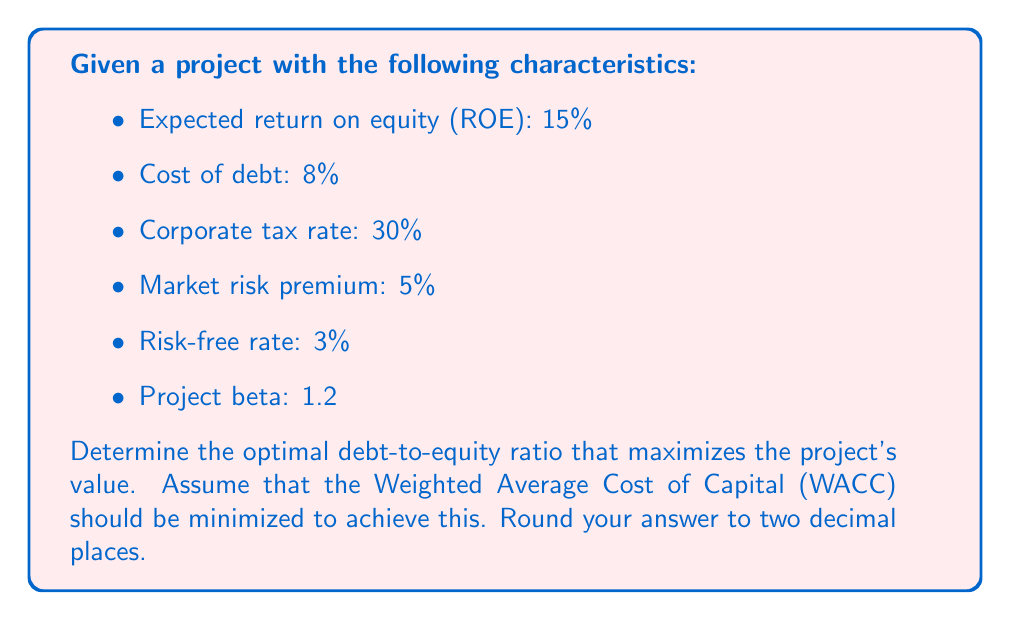Can you solve this math problem? To determine the optimal debt-to-equity ratio, we need to minimize the Weighted Average Cost of Capital (WACC). We'll use the following steps:

1. Calculate the cost of equity using the Capital Asset Pricing Model (CAPM):
   $$ K_e = R_f + \beta(R_m - R_f) $$
   Where:
   $K_e$ = Cost of equity
   $R_f$ = Risk-free rate
   $\beta$ = Project beta
   $R_m - R_f$ = Market risk premium

   $$ K_e = 3\% + 1.2(5\%) = 9\% $$

2. Calculate the after-tax cost of debt:
   $$ K_d(1-t) = 8\%(1-0.30) = 5.6\% $$

3. Set up the WACC equation:
   $$ WACC = w_e K_e + w_d K_d(1-t) $$
   Where:
   $w_e$ = Weight of equity
   $w_d$ = Weight of debt

4. Express $w_e$ in terms of $w_d$:
   $$ w_e = 1 - w_d $$

5. Substitute into the WACC equation:
   $$ WACC = (1-w_d)(9\%) + w_d(5.6\%) $$

6. Simplify:
   $$ WACC = 9\% - 9\%w_d + 5.6\%w_d = 9\% - 3.4\%w_d $$

7. To minimize WACC, we want to maximize $w_d$. However, we need to consider the trade-off between tax benefits and financial distress costs. A common rule of thumb is to limit debt to 50% of the capital structure.

8. Set $w_d = 0.5$ (50% debt):
   $$ WACC = 9\% - 3.4\%(0.5) = 7.3\% $$

9. Calculate the debt-to-equity ratio:
   $$ \text{D/E ratio} = \frac{w_d}{w_e} = \frac{0.5}{0.5} = 1 $$

Therefore, the optimal debt-to-equity ratio that maximizes the project's value by minimizing WACC is 1.00, or 1:1.
Answer: 1.00 